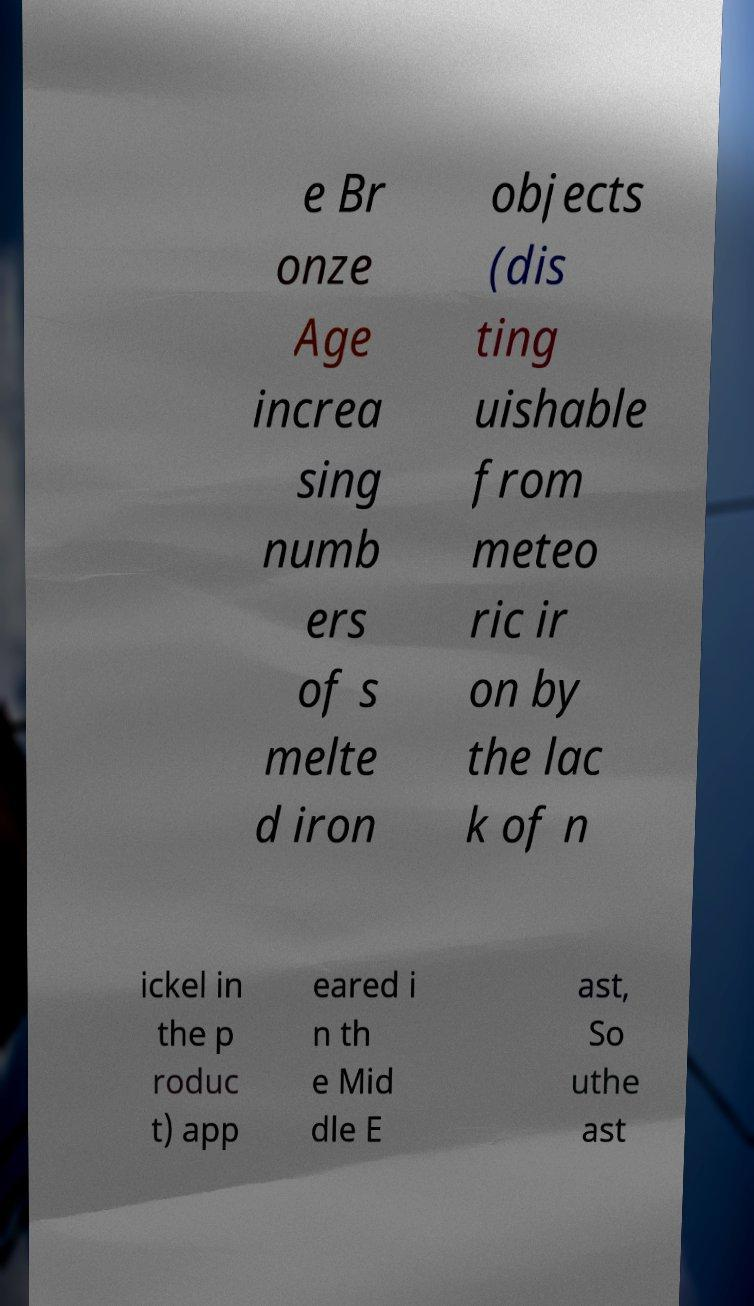Can you accurately transcribe the text from the provided image for me? e Br onze Age increa sing numb ers of s melte d iron objects (dis ting uishable from meteo ric ir on by the lac k of n ickel in the p roduc t) app eared i n th e Mid dle E ast, So uthe ast 